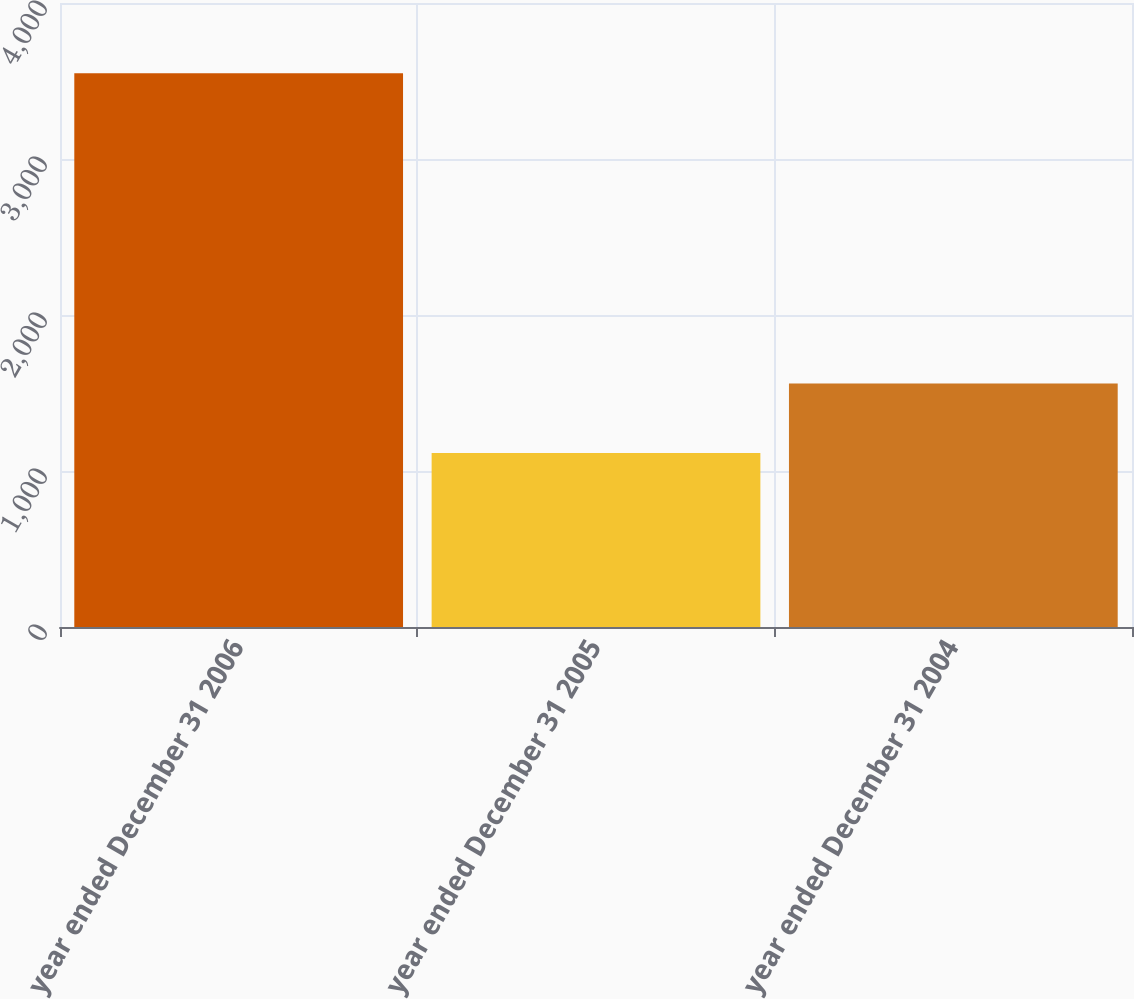<chart> <loc_0><loc_0><loc_500><loc_500><bar_chart><fcel>year ended December 31 2006<fcel>year ended December 31 2005<fcel>year ended December 31 2004<nl><fcel>3549<fcel>1116<fcel>1561<nl></chart> 